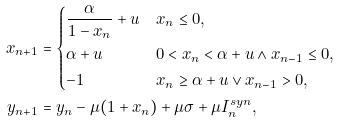Convert formula to latex. <formula><loc_0><loc_0><loc_500><loc_500>x _ { n + 1 } & = \begin{dcases} \frac { \alpha } { 1 - x _ { n } } + u & x _ { n } \leq 0 , \\ \alpha + u & 0 < x _ { n } < \alpha + u \wedge x _ { n - 1 } \leq 0 , \\ - 1 & x _ { n } \geq \alpha + u \lor x _ { n - 1 } > 0 , \end{dcases} \\ y _ { n + 1 } & = y _ { n } - \mu ( 1 + x _ { n } ) + \mu \sigma + \mu I ^ { s y n } _ { n } , \\</formula> 